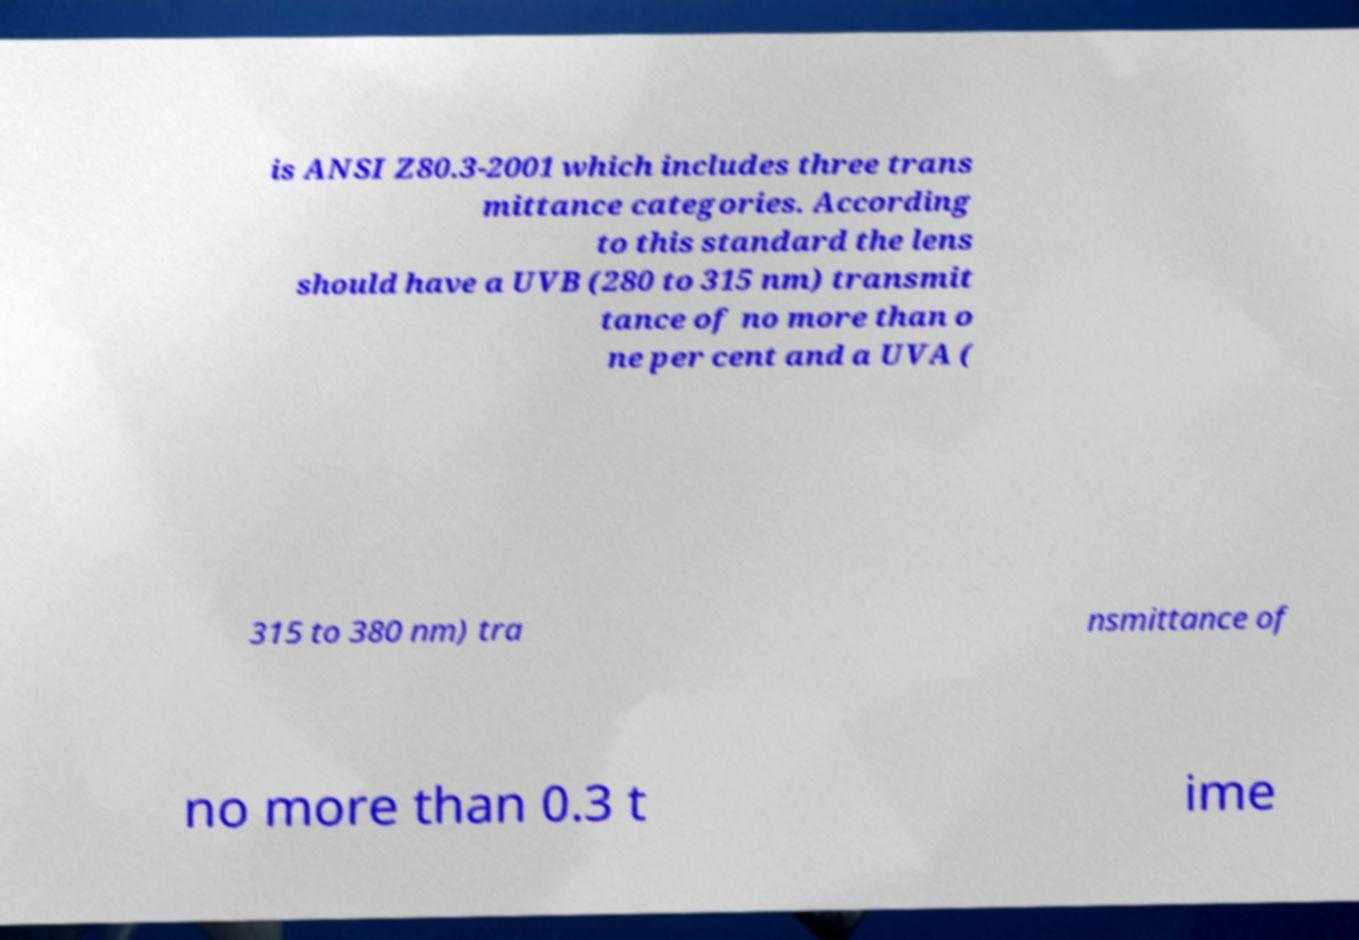I need the written content from this picture converted into text. Can you do that? is ANSI Z80.3-2001 which includes three trans mittance categories. According to this standard the lens should have a UVB (280 to 315 nm) transmit tance of no more than o ne per cent and a UVA ( 315 to 380 nm) tra nsmittance of no more than 0.3 t ime 